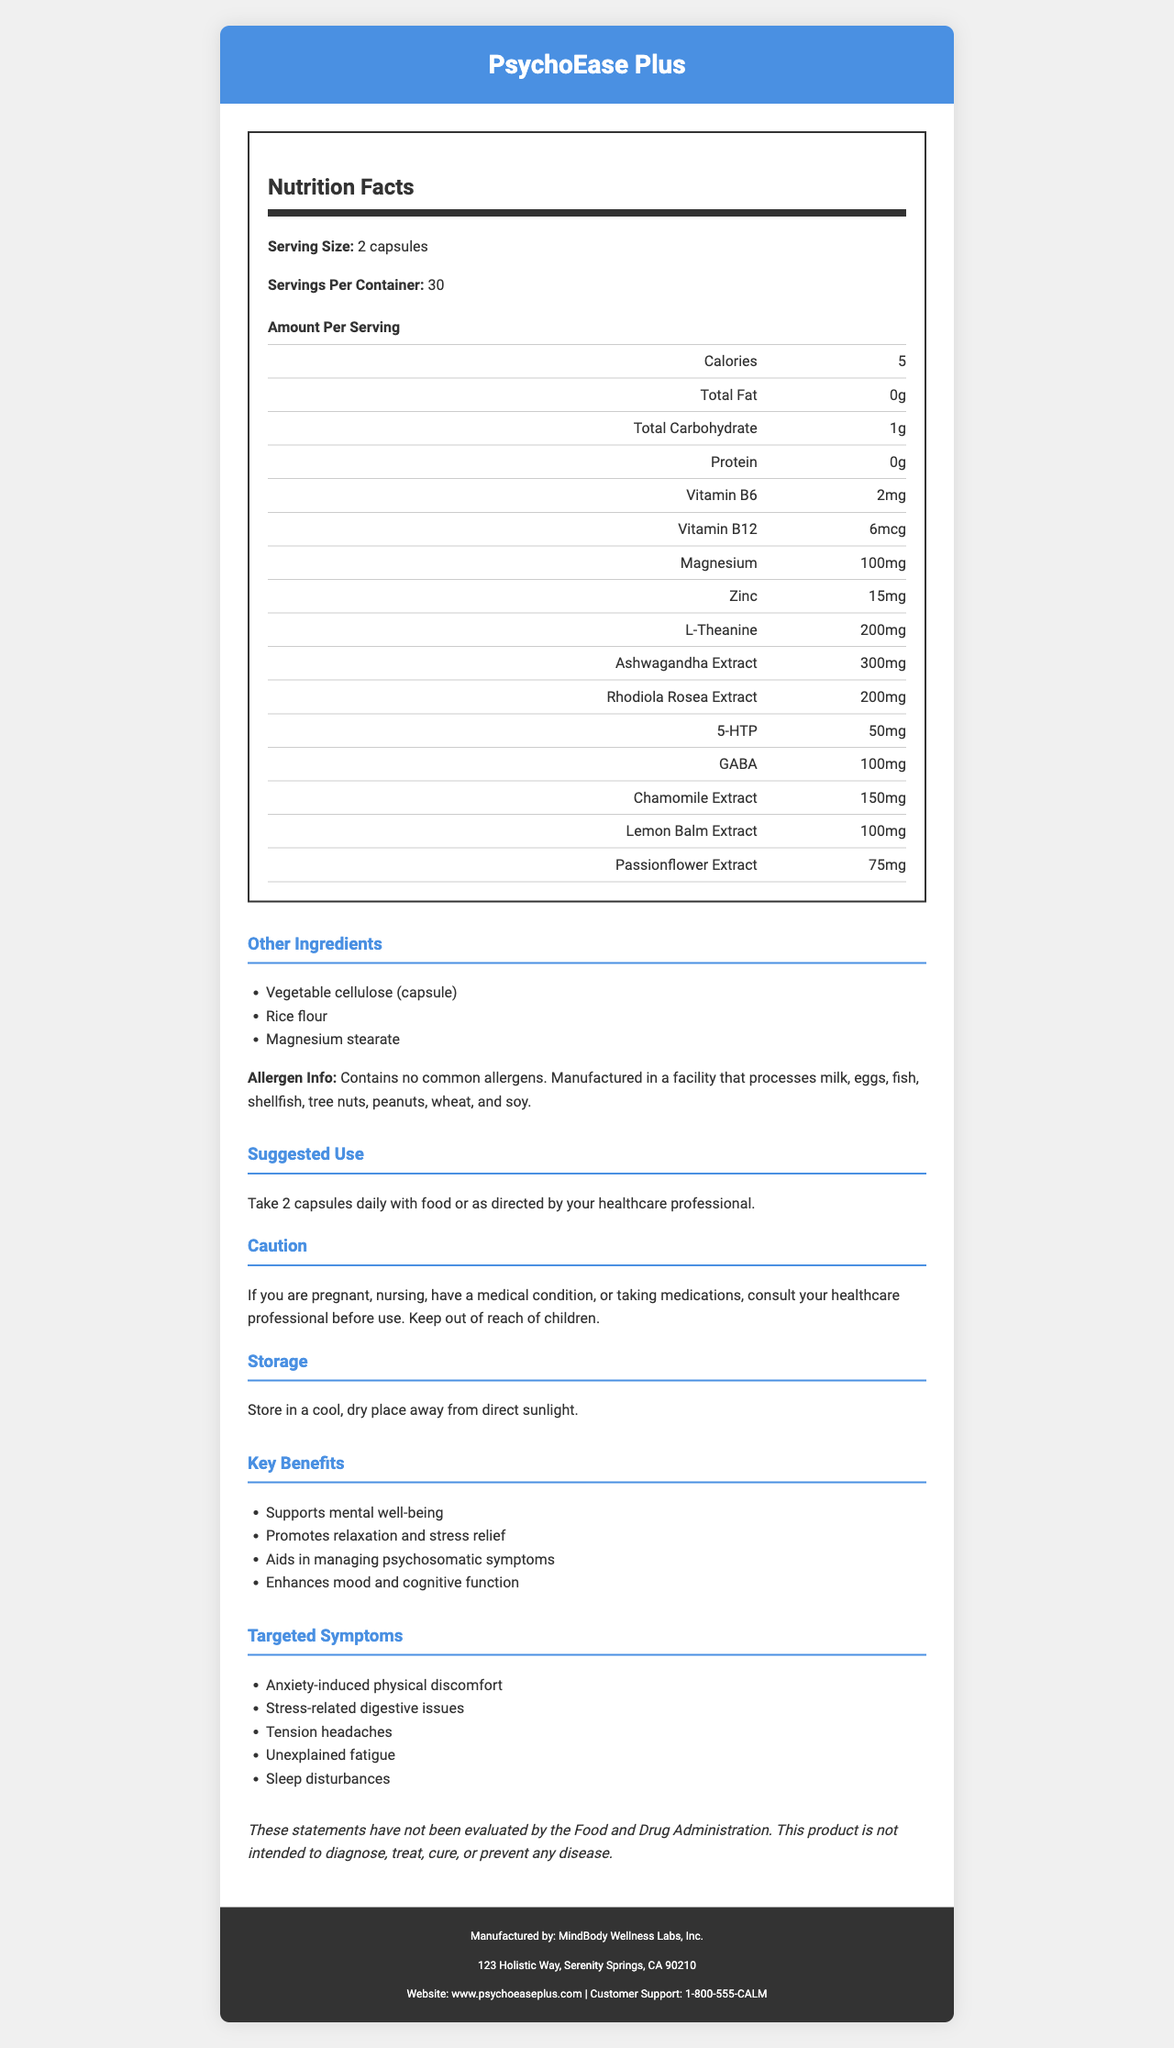what is the serving size of PsychoEase Plus? The document clearly states that the serving size is 2 capsules.
Answer: 2 capsules how many calories are in each serving of PsychoEase Plus? According to the Nutrition Facts section, each serving contains 5 calories.
Answer: 5 calories what is the amount of magnesium per serving? The document specifies that each serving contains 100mg of magnesium.
Answer: 100mg list three key benefits of PsychoEase Plus. These key benefits are listed under the 'Key Benefits' section.
Answer: Supports mental well-being, Promotes relaxation and stress relief, Aids in managing psychosomatic symptoms what is the suggested use for PsychoEase Plus? The suggested use is clearly mentioned in the document.
Answer: Take 2 capsules daily with food or as directed by your healthcare professional. which ingredient is present in the highest quantity per serving? A. Vitamin B6 B. Magnesium C. L-Theanine D. Ashwagandha Extract The amounts are given, and Ashwagandha Extract has 300mg per serving, which is the highest among the listed ingredients.
Answer: D. Ashwagandha Extract how many servings are there in one container? A. 20 B. 25 C. 30 D. 35 The document states that there are 30 servings per container.
Answer: C. 30 does PsychoEase Plus contain any common allergens? Yes/No The document states that it contains no common allergens.
Answer: No describe the main idea of the document. The document is essentially a detailed brochure or label for a supplement product designed to support mental well-being and alleviate psychosomatic symptoms.
Answer: The document provides detailed information about a supplement called PsychoEase Plus, including its nutrition facts, ingredients, key benefits, targeted symptoms, suggested use, cautions, storage instructions, and allergen information. does the product claim to be evaluated by FDA? The disclaimer clearly states that the statements have not been evaluated by the Food and Drug Administration.
Answer: No how much zinc is in each serving of PsychoEase Plus? The document lists zinc as having 15mg per serving.
Answer: 15mg why might someone need to consult a healthcare professional before using PsychoEase Plus? The caution section mentions these specific situations where consulting a healthcare professional is advised.
Answer: If you are pregnant, nursing, have a medical condition, or taking medications. what is the total carbohydrate content per serving? The document lists the total carbohydrate content as 1g per serving.
Answer: 1g what is the manufacturer's address? The manufacturer's address is clearly mentioned in the footer of the document.
Answer: 123 Holistic Way, Serenity Springs, CA 90210 how should the product be stored? The storage instructions are provided in the document.
Answer: Store in a cool, dry place away from direct sunlight. is the exact cause of psychosomatic symptoms detailed in the document? The document lists targeted symptoms but does not provide detailed information about the exact causes of psychosomatic symptoms.
Answer: Not enough information 